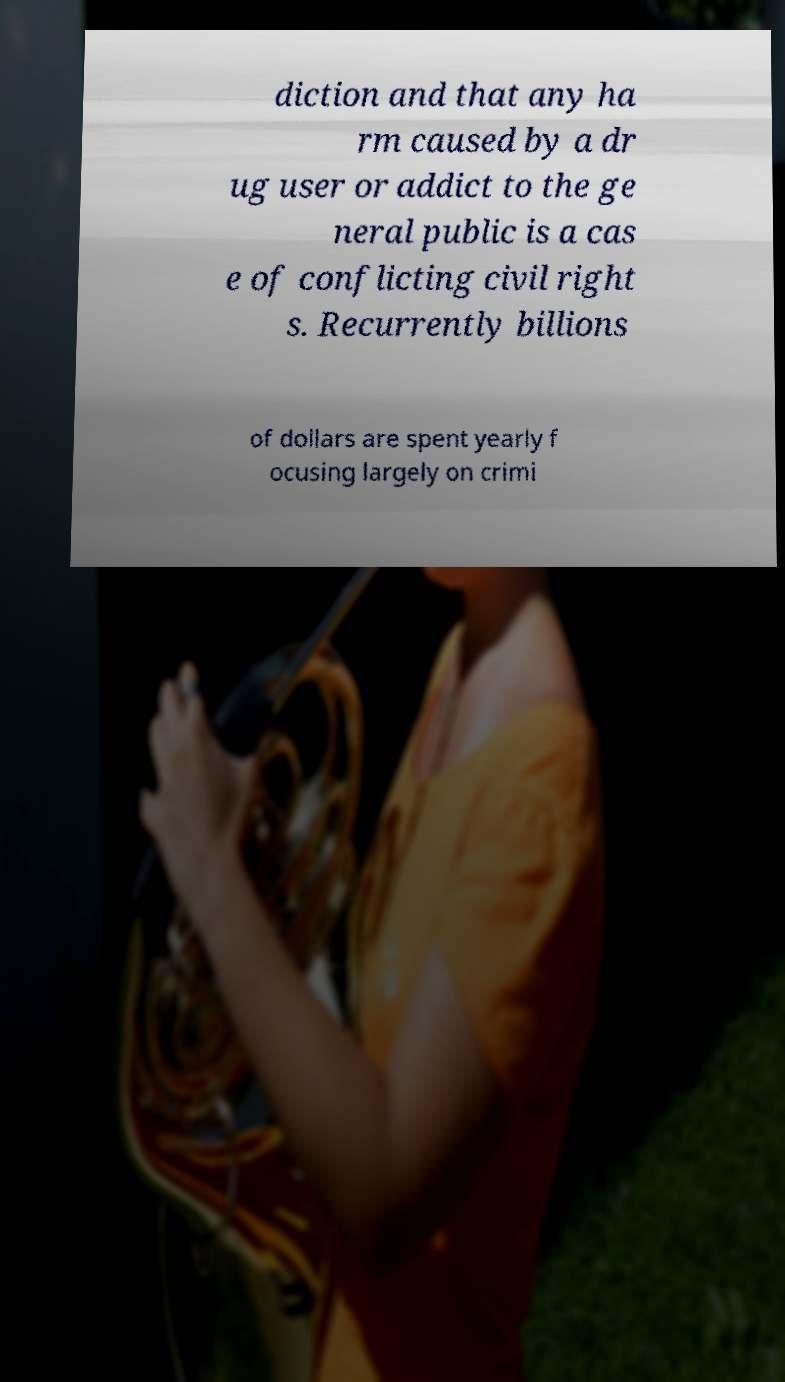For documentation purposes, I need the text within this image transcribed. Could you provide that? diction and that any ha rm caused by a dr ug user or addict to the ge neral public is a cas e of conflicting civil right s. Recurrently billions of dollars are spent yearly f ocusing largely on crimi 